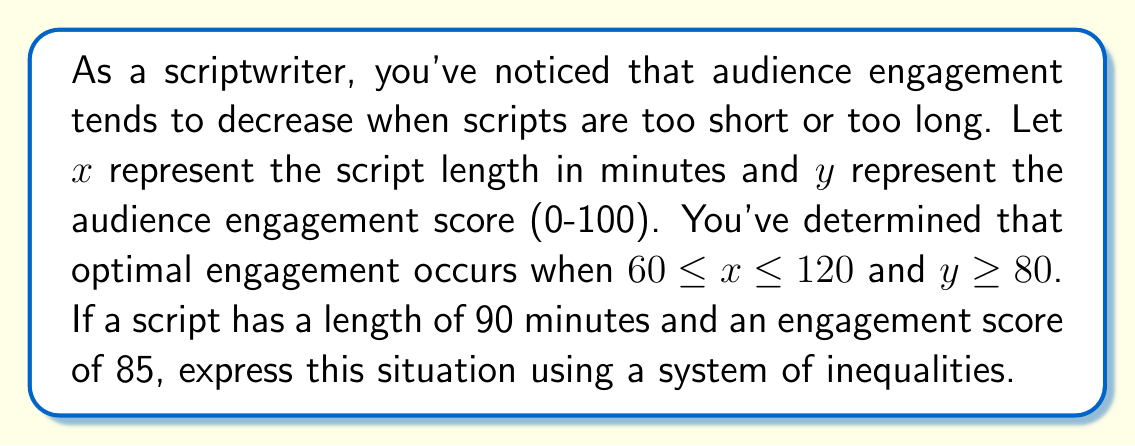Teach me how to tackle this problem. To express this situation using a system of inequalities, we need to consider both the script length and the audience engagement score:

1. Script length ($x$):
   The given script length is 90 minutes, which falls within the optimal range of 60 to 120 minutes.
   We can express this as: $60 \leq 90 \leq 120$

2. Audience engagement score ($y$):
   The given engagement score is 85, which is above the minimum optimal score of 80.
   We can express this as: $85 \geq 80$

3. Combining these inequalities:
   For the script length: $60 \leq x \leq 120$
   For the engagement score: $y \geq 80$

4. The specific values for this script:
   $x = 90$
   $y = 85$

5. Putting it all together, we can express the system of inequalities as:
   $$\begin{cases}
   60 \leq x \leq 120 \\
   y \geq 80 \\
   x = 90 \\
   y = 85
   \end{cases}$$

This system of inequalities represents the optimal engagement range for script length, the minimum engagement score, and the specific values for the given script.
Answer: $$\begin{cases}
60 \leq x \leq 120 \\
y \geq 80 \\
x = 90 \\
y = 85
\end{cases}$$ 